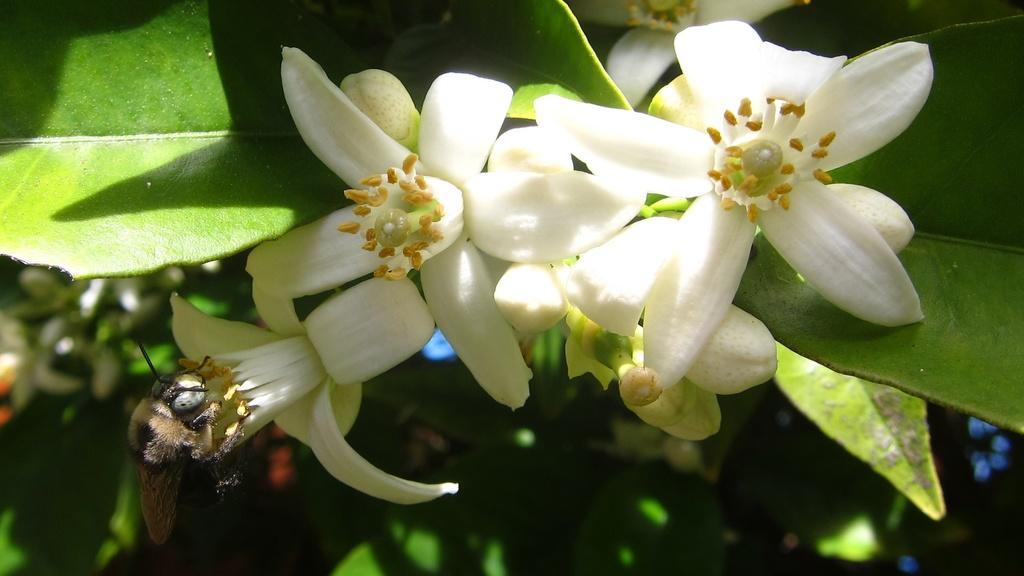Can you describe this image briefly? This image consists of white flowers on which there is a honey bee sitting. In the background, there are green leaves. 